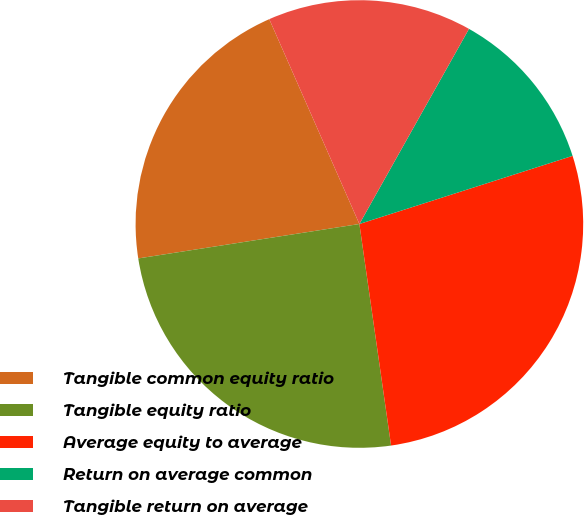Convert chart to OTSL. <chart><loc_0><loc_0><loc_500><loc_500><pie_chart><fcel>Tangible common equity ratio<fcel>Tangible equity ratio<fcel>Average equity to average<fcel>Return on average common<fcel>Tangible return on average<nl><fcel>20.86%<fcel>24.8%<fcel>27.66%<fcel>11.93%<fcel>14.74%<nl></chart> 